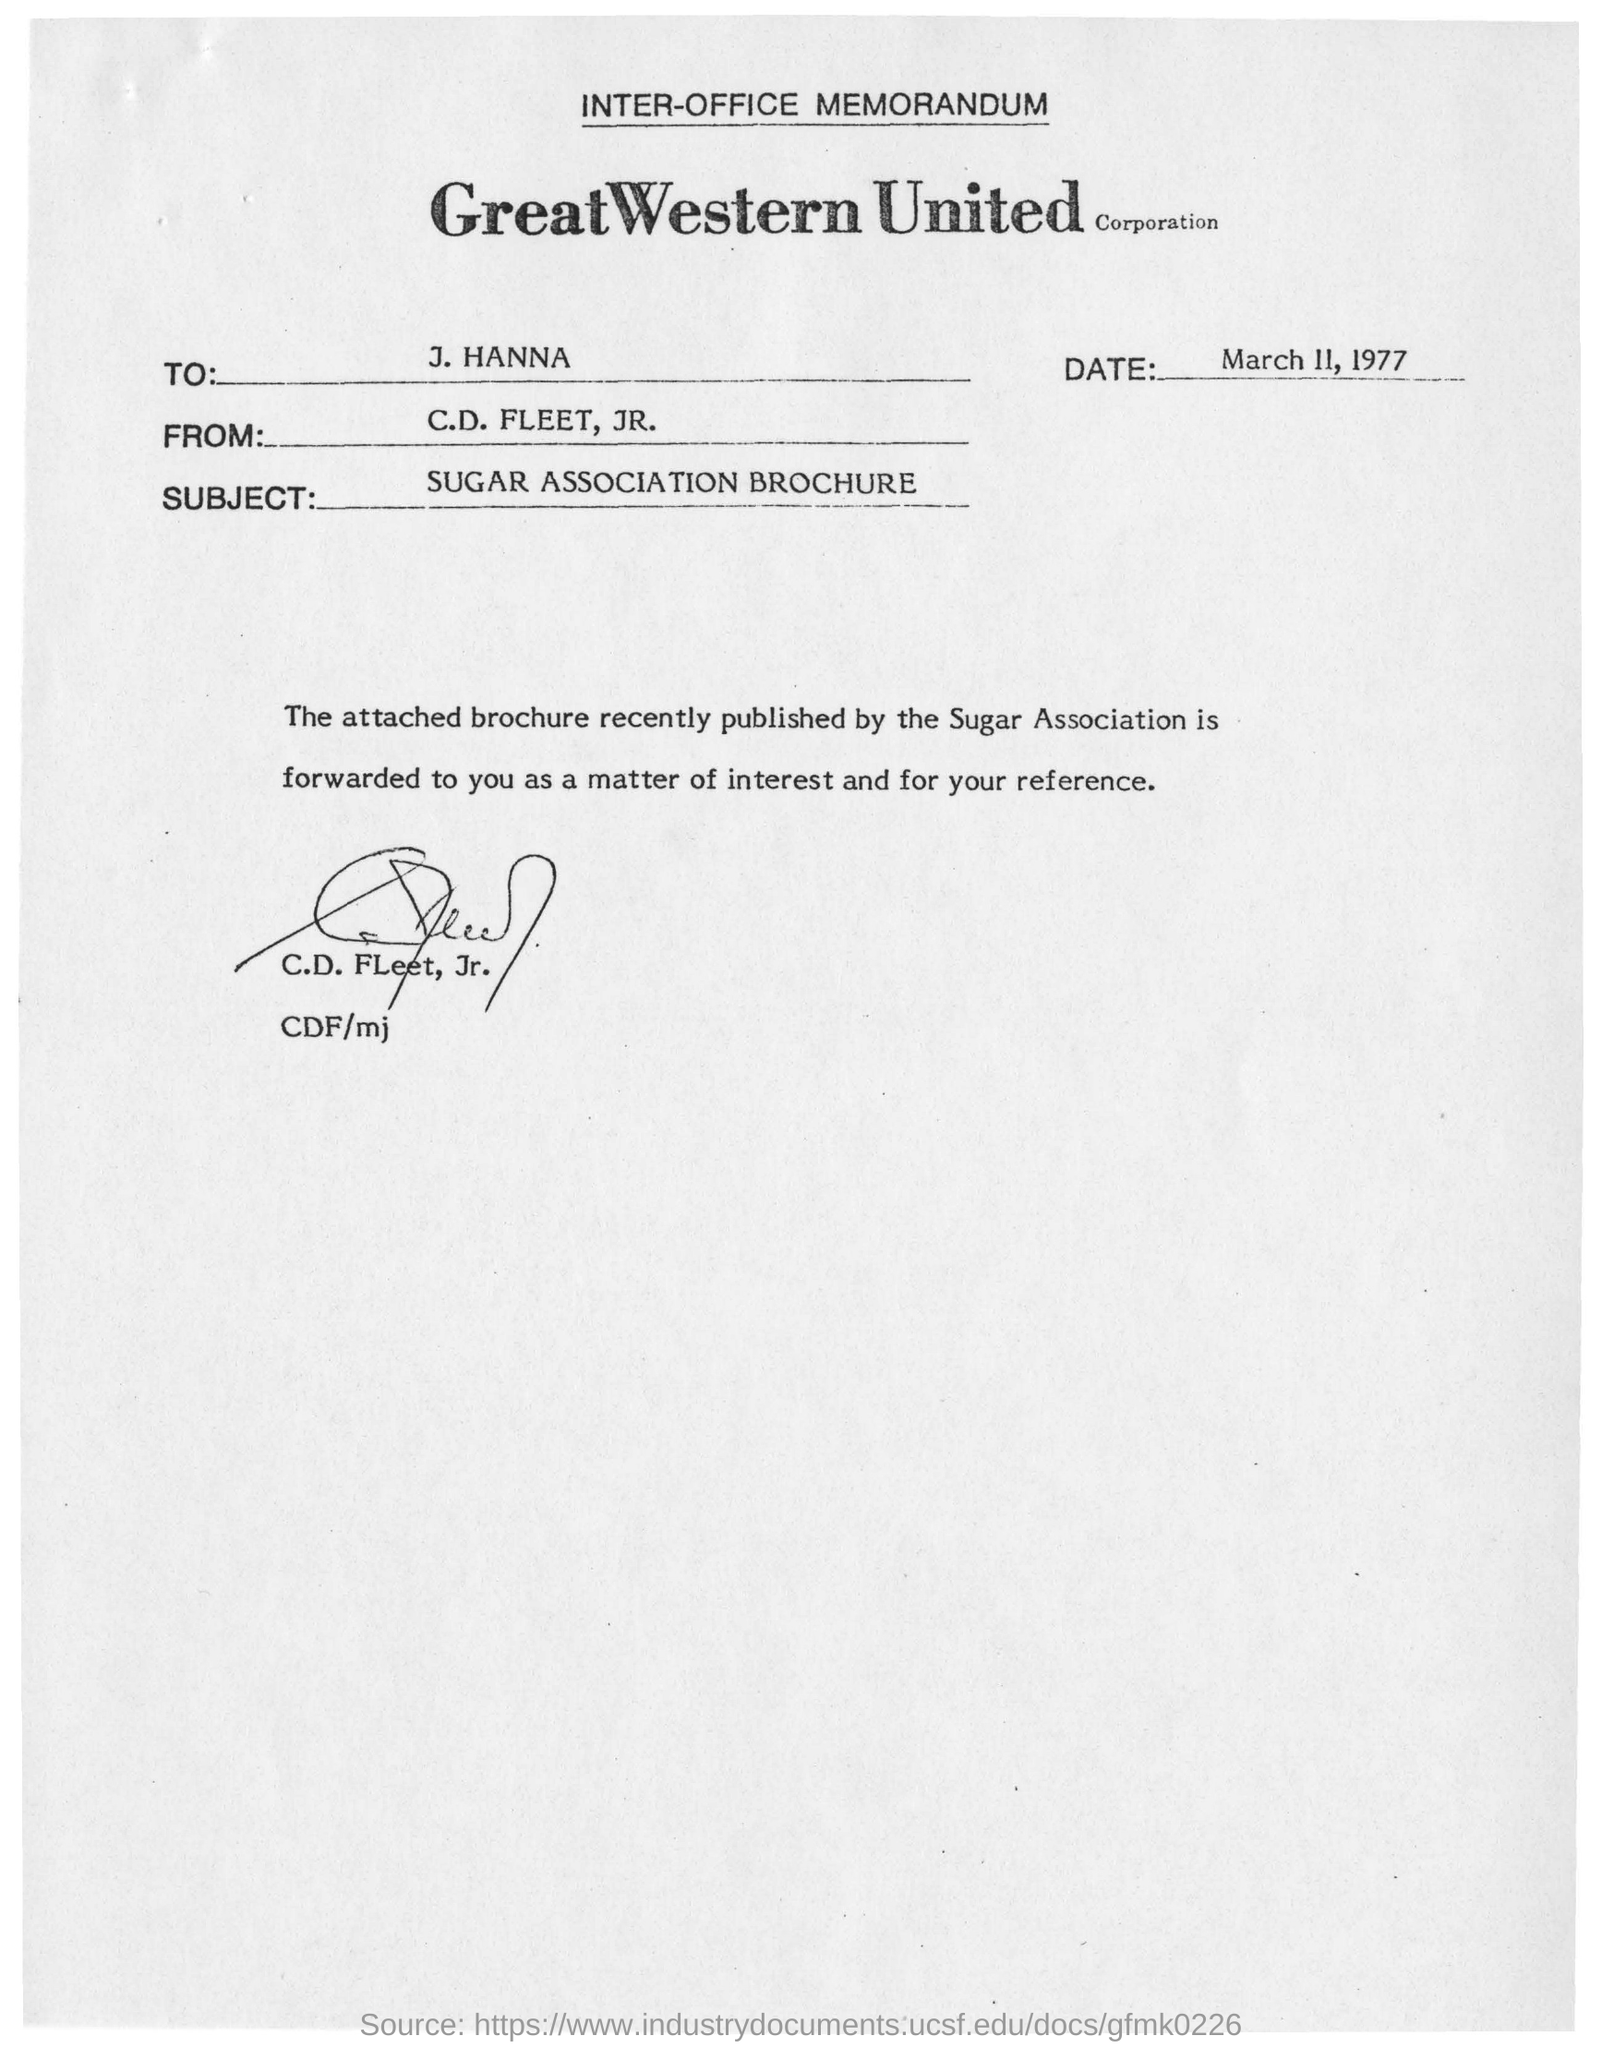Give some essential details in this illustration. The memorandum states that the date is March 11, 1977. The subject of the memorandum is the Sugar Association brochure. To whom is this memorandum addressed? The answer is J. Hanna. 